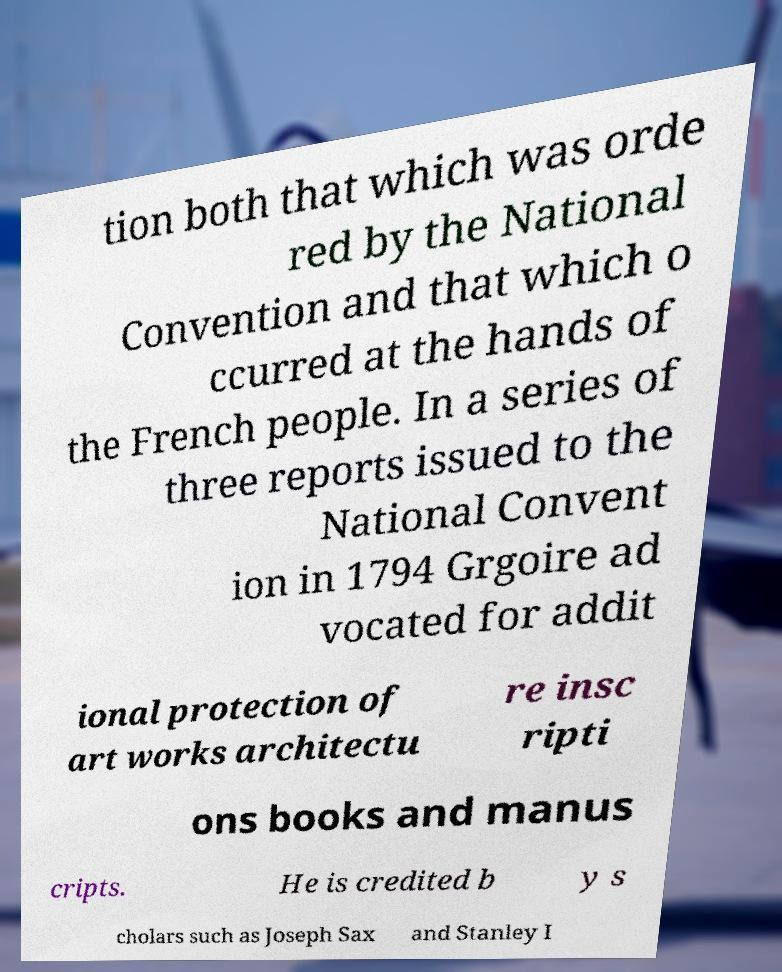Could you assist in decoding the text presented in this image and type it out clearly? tion both that which was orde red by the National Convention and that which o ccurred at the hands of the French people. In a series of three reports issued to the National Convent ion in 1794 Grgoire ad vocated for addit ional protection of art works architectu re insc ripti ons books and manus cripts. He is credited b y s cholars such as Joseph Sax and Stanley I 